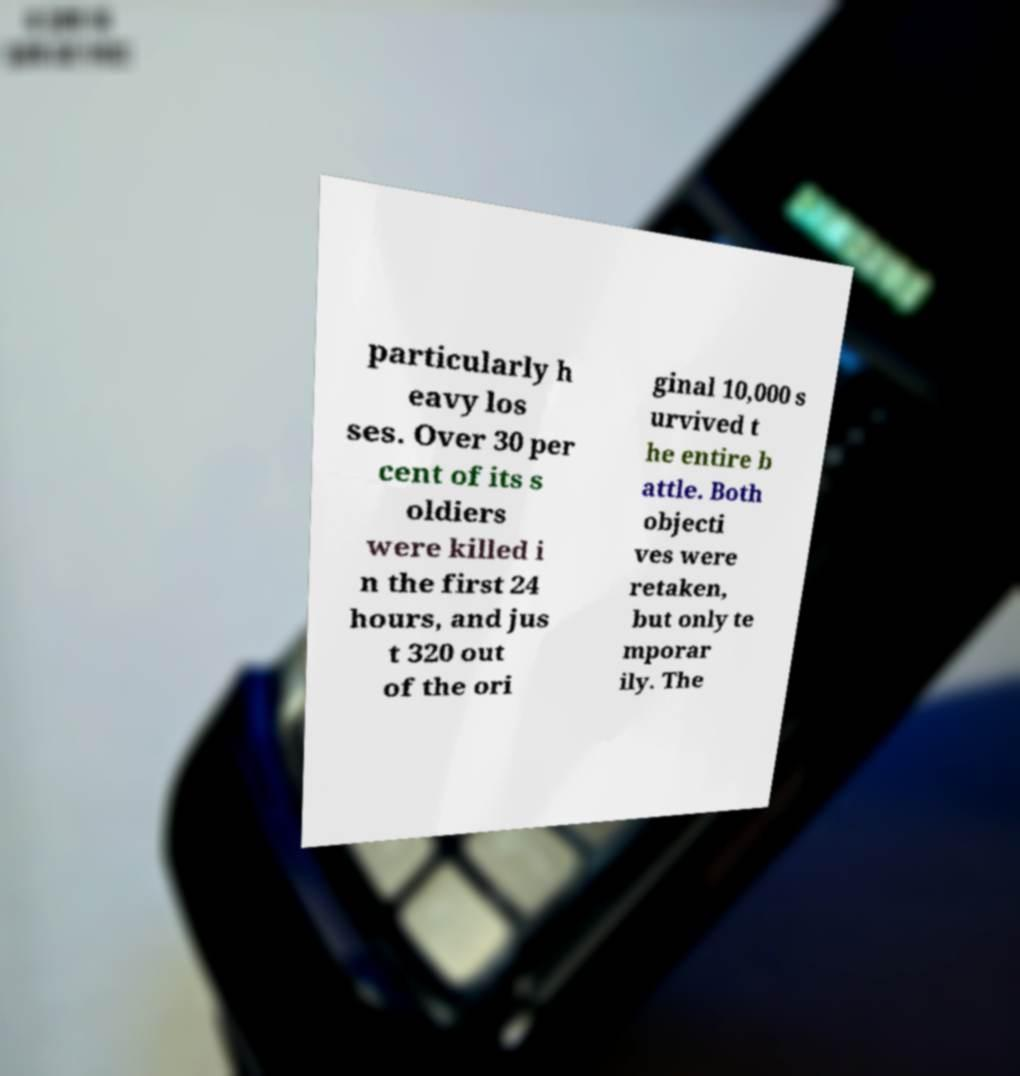There's text embedded in this image that I need extracted. Can you transcribe it verbatim? particularly h eavy los ses. Over 30 per cent of its s oldiers were killed i n the first 24 hours, and jus t 320 out of the ori ginal 10,000 s urvived t he entire b attle. Both objecti ves were retaken, but only te mporar ily. The 